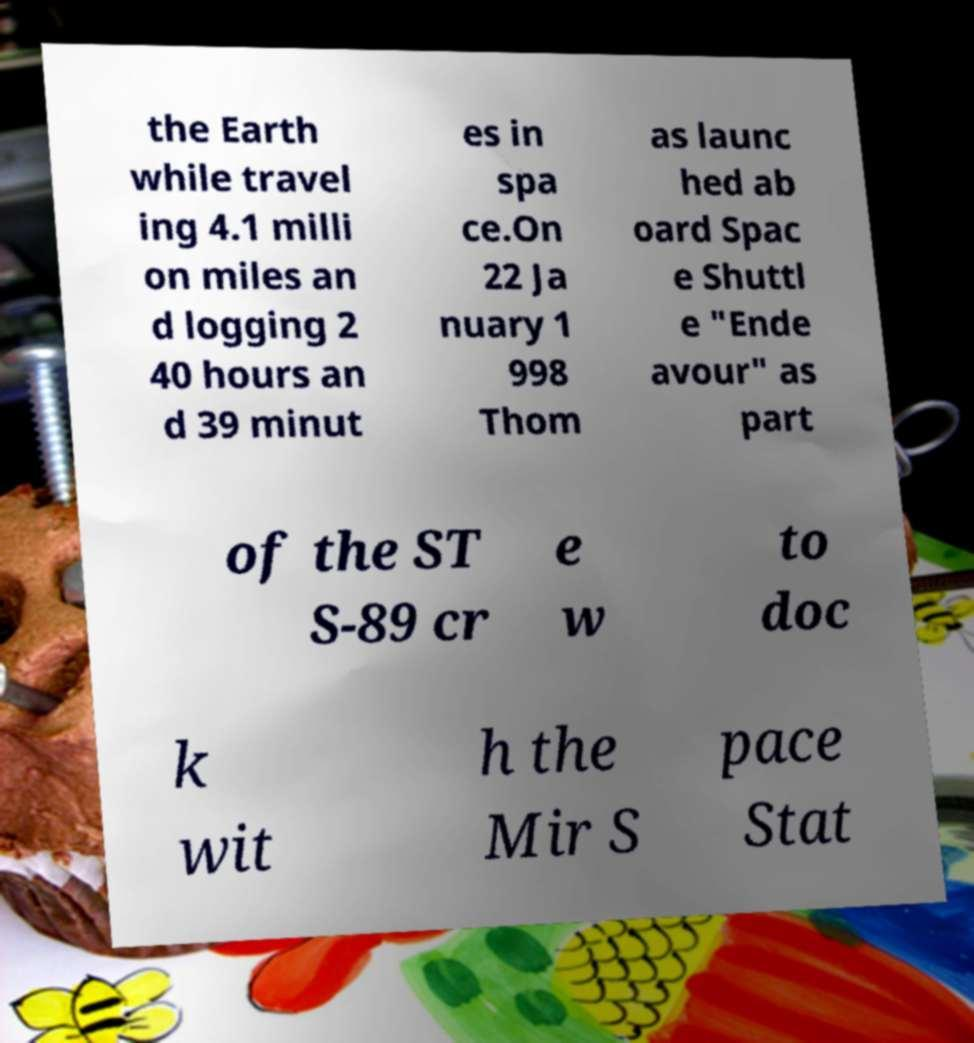Could you assist in decoding the text presented in this image and type it out clearly? the Earth while travel ing 4.1 milli on miles an d logging 2 40 hours an d 39 minut es in spa ce.On 22 Ja nuary 1 998 Thom as launc hed ab oard Spac e Shuttl e "Ende avour" as part of the ST S-89 cr e w to doc k wit h the Mir S pace Stat 